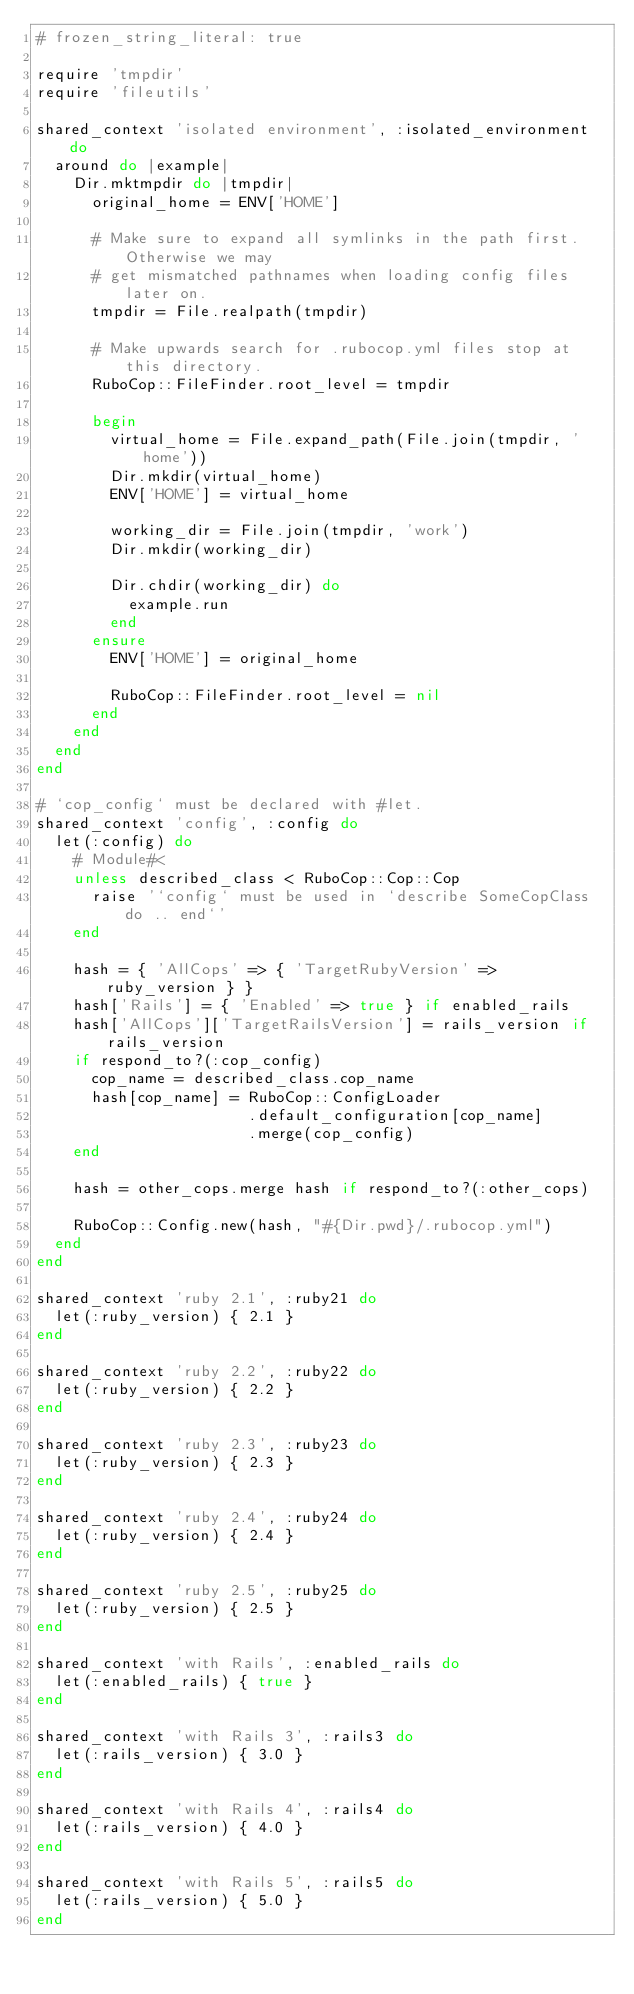Convert code to text. <code><loc_0><loc_0><loc_500><loc_500><_Ruby_># frozen_string_literal: true

require 'tmpdir'
require 'fileutils'

shared_context 'isolated environment', :isolated_environment do
  around do |example|
    Dir.mktmpdir do |tmpdir|
      original_home = ENV['HOME']

      # Make sure to expand all symlinks in the path first. Otherwise we may
      # get mismatched pathnames when loading config files later on.
      tmpdir = File.realpath(tmpdir)

      # Make upwards search for .rubocop.yml files stop at this directory.
      RuboCop::FileFinder.root_level = tmpdir

      begin
        virtual_home = File.expand_path(File.join(tmpdir, 'home'))
        Dir.mkdir(virtual_home)
        ENV['HOME'] = virtual_home

        working_dir = File.join(tmpdir, 'work')
        Dir.mkdir(working_dir)

        Dir.chdir(working_dir) do
          example.run
        end
      ensure
        ENV['HOME'] = original_home

        RuboCop::FileFinder.root_level = nil
      end
    end
  end
end

# `cop_config` must be declared with #let.
shared_context 'config', :config do
  let(:config) do
    # Module#<
    unless described_class < RuboCop::Cop::Cop
      raise '`config` must be used in `describe SomeCopClass do .. end`'
    end

    hash = { 'AllCops' => { 'TargetRubyVersion' => ruby_version } }
    hash['Rails'] = { 'Enabled' => true } if enabled_rails
    hash['AllCops']['TargetRailsVersion'] = rails_version if rails_version
    if respond_to?(:cop_config)
      cop_name = described_class.cop_name
      hash[cop_name] = RuboCop::ConfigLoader
                       .default_configuration[cop_name]
                       .merge(cop_config)
    end

    hash = other_cops.merge hash if respond_to?(:other_cops)

    RuboCop::Config.new(hash, "#{Dir.pwd}/.rubocop.yml")
  end
end

shared_context 'ruby 2.1', :ruby21 do
  let(:ruby_version) { 2.1 }
end

shared_context 'ruby 2.2', :ruby22 do
  let(:ruby_version) { 2.2 }
end

shared_context 'ruby 2.3', :ruby23 do
  let(:ruby_version) { 2.3 }
end

shared_context 'ruby 2.4', :ruby24 do
  let(:ruby_version) { 2.4 }
end

shared_context 'ruby 2.5', :ruby25 do
  let(:ruby_version) { 2.5 }
end

shared_context 'with Rails', :enabled_rails do
  let(:enabled_rails) { true }
end

shared_context 'with Rails 3', :rails3 do
  let(:rails_version) { 3.0 }
end

shared_context 'with Rails 4', :rails4 do
  let(:rails_version) { 4.0 }
end

shared_context 'with Rails 5', :rails5 do
  let(:rails_version) { 5.0 }
end
</code> 